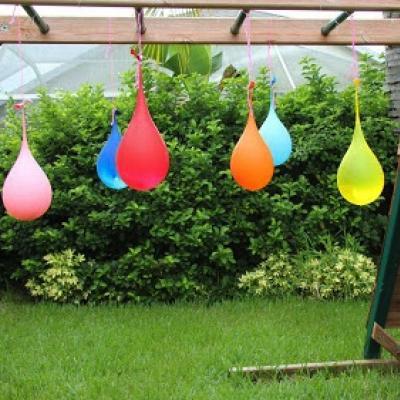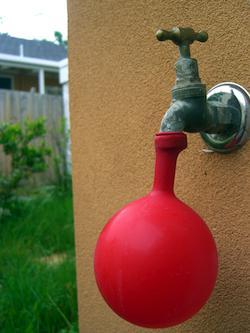The first image is the image on the left, the second image is the image on the right. Assess this claim about the two images: "A partially filled balloon is attached to a faucet.". Correct or not? Answer yes or no. Yes. The first image is the image on the left, the second image is the image on the right. Analyze the images presented: Is the assertion "In at least one image there is a single balloon being filled from a water faucet." valid? Answer yes or no. Yes. 